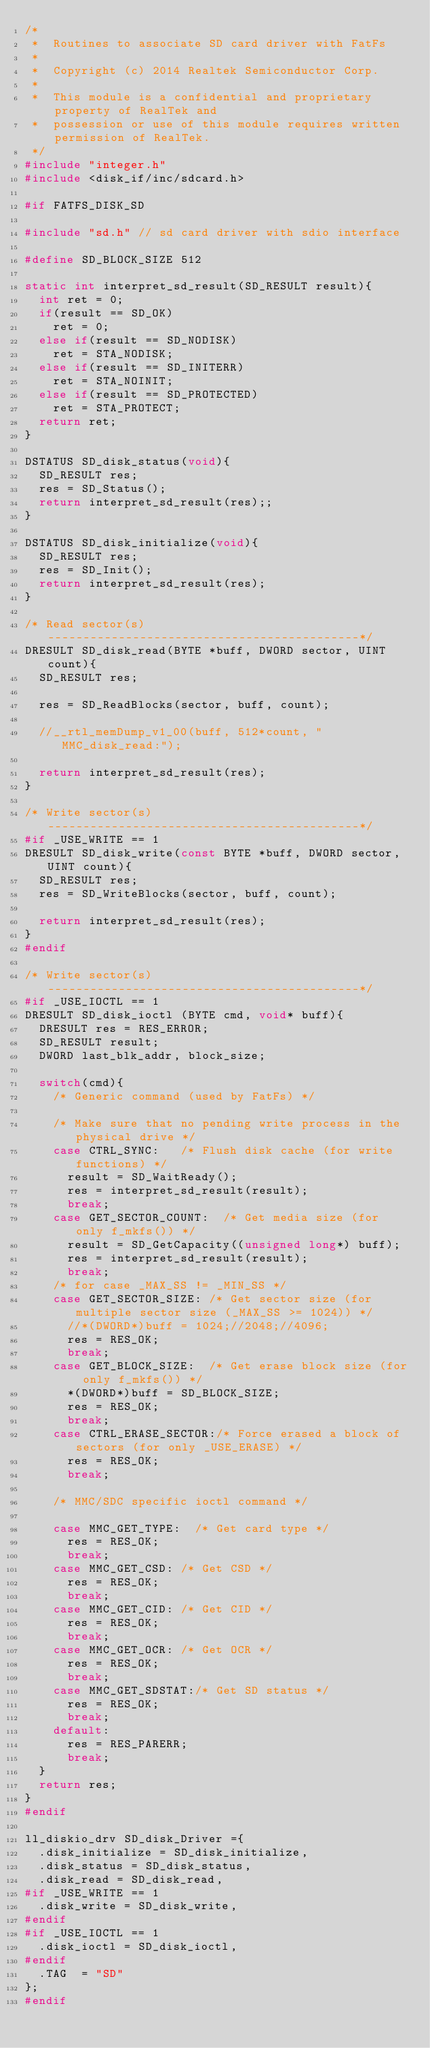<code> <loc_0><loc_0><loc_500><loc_500><_C_>/*
 *  Routines to associate SD card driver with FatFs
 *
 *  Copyright (c) 2014 Realtek Semiconductor Corp.
 *
 *  This module is a confidential and proprietary property of RealTek and
 *  possession or use of this module requires written permission of RealTek.
 */
#include "integer.h"
#include <disk_if/inc/sdcard.h>

#if	FATFS_DISK_SD

#include "sd.h" // sd card driver with sdio interface

#define SD_BLOCK_SIZE	512

static int interpret_sd_result(SD_RESULT result){
	int ret = 0;
	if(result == SD_OK)
		ret = 0;
	else if(result == SD_NODISK)
		ret = STA_NODISK;
	else if(result == SD_INITERR)
		ret = STA_NOINIT;
	else if(result == SD_PROTECTED)
		ret = STA_PROTECT;
	return ret;
}

DSTATUS SD_disk_status(void){
	SD_RESULT res;
	res = SD_Status();
	return interpret_sd_result(res);;
}

DSTATUS SD_disk_initialize(void){
	SD_RESULT res;
	res = SD_Init();
	return interpret_sd_result(res);
}

/* Read sector(s) --------------------------------------------*/
DRESULT SD_disk_read(BYTE *buff, DWORD sector, UINT count){
	SD_RESULT res;

	res = SD_ReadBlocks(sector, buff, count);

	//__rtl_memDump_v1_00(buff, 512*count, "MMC_disk_read:");
	
	return interpret_sd_result(res);
}

/* Write sector(s) --------------------------------------------*/
#if _USE_WRITE == 1
DRESULT SD_disk_write(const BYTE *buff, DWORD sector, UINT count){
	SD_RESULT res;
	res = SD_WriteBlocks(sector, buff, count);
	
	return interpret_sd_result(res);
}
#endif

/* Write sector(s) --------------------------------------------*/
#if _USE_IOCTL == 1
DRESULT SD_disk_ioctl (BYTE cmd, void* buff){
	DRESULT res = RES_ERROR;
	SD_RESULT result;
	DWORD last_blk_addr, block_size;

	switch(cmd){
		/* Generic command (used by FatFs) */
		
		/* Make sure that no pending write process in the physical drive */
		case CTRL_SYNC:		/* Flush disk cache (for write functions) */
			result = SD_WaitReady();
			res = interpret_sd_result(result);
			break;
		case GET_SECTOR_COUNT:	/* Get media size (for only f_mkfs()) */
			result = SD_GetCapacity((unsigned long*) buff);
			res = interpret_sd_result(result);
			break;
		/* for case _MAX_SS != _MIN_SS */
		case GET_SECTOR_SIZE:	/* Get sector size (for multiple sector size (_MAX_SS >= 1024)) */
			//*(DWORD*)buff = 1024;//2048;//4096;
			res = RES_OK;
			break;
		case GET_BLOCK_SIZE:	/* Get erase block size (for only f_mkfs()) */
			*(DWORD*)buff = SD_BLOCK_SIZE;
			res = RES_OK;
			break;
		case CTRL_ERASE_SECTOR:/* Force erased a block of sectors (for only _USE_ERASE) */
			res = RES_OK;
			break;

		/* MMC/SDC specific ioctl command */

		case MMC_GET_TYPE:	/* Get card type */
			res = RES_OK;
			break;
		case MMC_GET_CSD:	/* Get CSD */
			res = RES_OK;
			break;
		case MMC_GET_CID:	/* Get CID */
			res = RES_OK;
			break;
		case MMC_GET_OCR:	/* Get OCR */
			res = RES_OK;
			break;
		case MMC_GET_SDSTAT:/* Get SD status */
			res = RES_OK;
			break;
		default:
			res = RES_PARERR;
			break;
	}
	return res;
}
#endif

ll_diskio_drv SD_disk_Driver ={
	.disk_initialize = SD_disk_initialize,
	.disk_status = SD_disk_status,
	.disk_read = SD_disk_read,
#if _USE_WRITE == 1
	.disk_write = SD_disk_write,
#endif
#if _USE_IOCTL == 1
	.disk_ioctl = SD_disk_ioctl,
#endif
	.TAG	= "SD"
};
#endif
</code> 